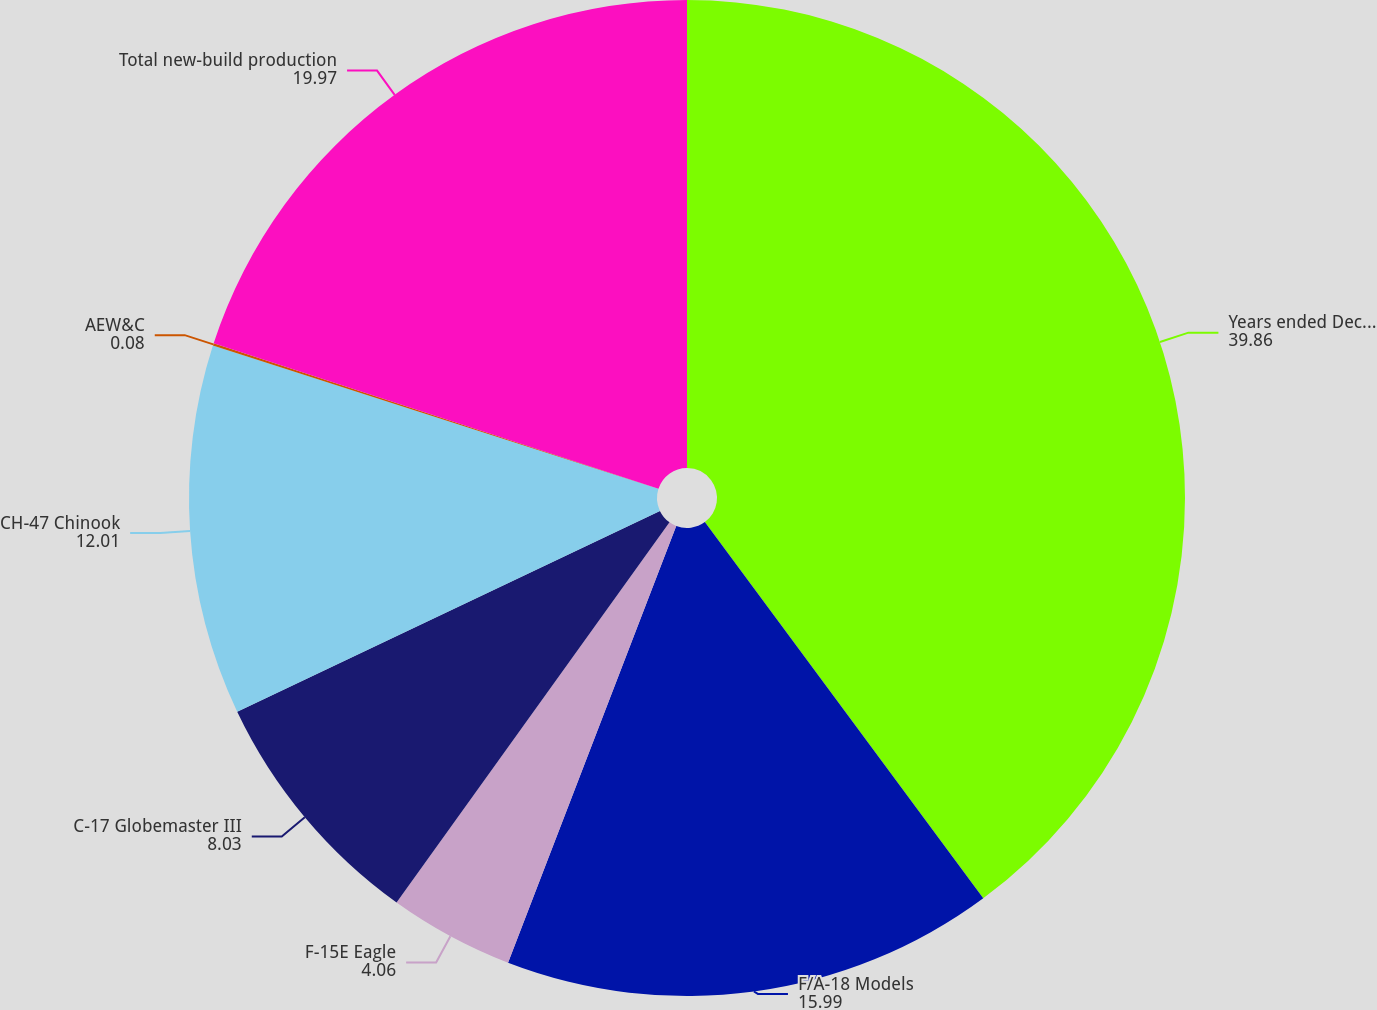Convert chart. <chart><loc_0><loc_0><loc_500><loc_500><pie_chart><fcel>Years ended December 31<fcel>F/A-18 Models<fcel>F-15E Eagle<fcel>C-17 Globemaster III<fcel>CH-47 Chinook<fcel>AEW&C<fcel>Total new-build production<nl><fcel>39.86%<fcel>15.99%<fcel>4.06%<fcel>8.03%<fcel>12.01%<fcel>0.08%<fcel>19.97%<nl></chart> 